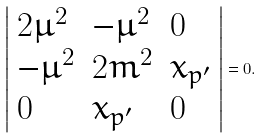Convert formula to latex. <formula><loc_0><loc_0><loc_500><loc_500>\left | \begin{array} { l l l l l } 2 \mu ^ { 2 } & - \mu ^ { 2 } & 0 \\ - \mu ^ { 2 } & 2 m ^ { 2 } & x _ { p ^ { \prime } } \\ 0 & x _ { p ^ { \prime } } & 0 \end{array} \right | = 0 .</formula> 